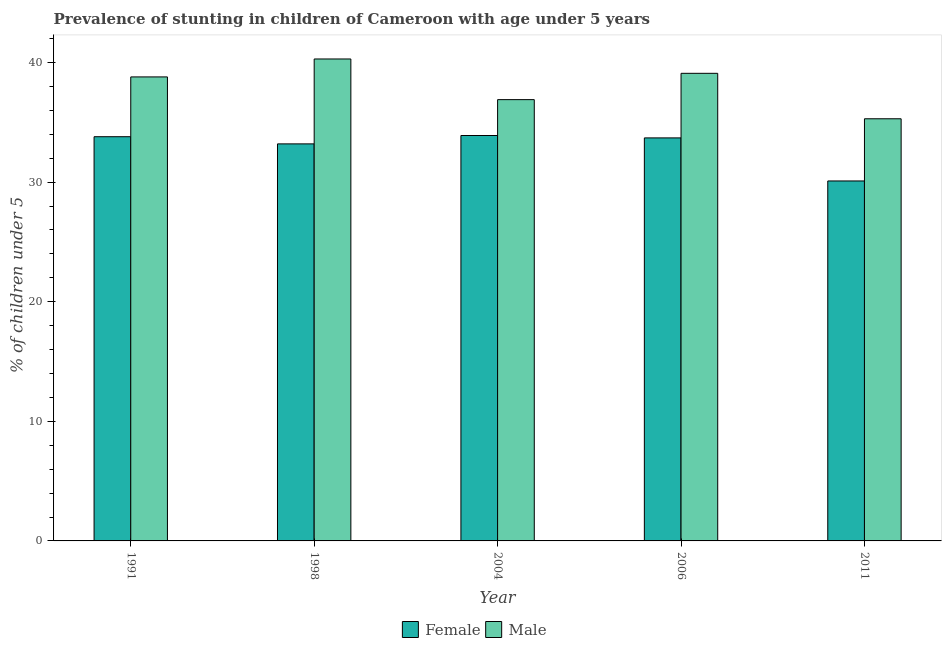Are the number of bars per tick equal to the number of legend labels?
Your answer should be compact. Yes. How many bars are there on the 1st tick from the left?
Offer a terse response. 2. What is the label of the 3rd group of bars from the left?
Your response must be concise. 2004. What is the percentage of stunted female children in 2011?
Your response must be concise. 30.1. Across all years, what is the maximum percentage of stunted female children?
Give a very brief answer. 33.9. Across all years, what is the minimum percentage of stunted female children?
Keep it short and to the point. 30.1. In which year was the percentage of stunted female children maximum?
Provide a succinct answer. 2004. What is the total percentage of stunted male children in the graph?
Your answer should be very brief. 190.4. What is the difference between the percentage of stunted female children in 1998 and that in 2011?
Give a very brief answer. 3.1. What is the difference between the percentage of stunted male children in 2006 and the percentage of stunted female children in 2004?
Make the answer very short. 2.2. What is the average percentage of stunted male children per year?
Provide a succinct answer. 38.08. In the year 1998, what is the difference between the percentage of stunted male children and percentage of stunted female children?
Your answer should be compact. 0. In how many years, is the percentage of stunted female children greater than 22 %?
Give a very brief answer. 5. What is the ratio of the percentage of stunted male children in 1991 to that in 2004?
Offer a very short reply. 1.05. Is the percentage of stunted female children in 1991 less than that in 2006?
Give a very brief answer. No. What is the difference between the highest and the second highest percentage of stunted male children?
Ensure brevity in your answer.  1.2. In how many years, is the percentage of stunted female children greater than the average percentage of stunted female children taken over all years?
Give a very brief answer. 4. What does the 2nd bar from the left in 1998 represents?
Keep it short and to the point. Male. Are all the bars in the graph horizontal?
Your answer should be compact. No. How many years are there in the graph?
Your answer should be very brief. 5. What is the difference between two consecutive major ticks on the Y-axis?
Your answer should be compact. 10. Does the graph contain grids?
Make the answer very short. No. How are the legend labels stacked?
Provide a succinct answer. Horizontal. What is the title of the graph?
Offer a very short reply. Prevalence of stunting in children of Cameroon with age under 5 years. What is the label or title of the Y-axis?
Keep it short and to the point.  % of children under 5. What is the  % of children under 5 of Female in 1991?
Your answer should be very brief. 33.8. What is the  % of children under 5 in Male in 1991?
Offer a very short reply. 38.8. What is the  % of children under 5 of Female in 1998?
Offer a terse response. 33.2. What is the  % of children under 5 in Male in 1998?
Your answer should be very brief. 40.3. What is the  % of children under 5 of Female in 2004?
Your response must be concise. 33.9. What is the  % of children under 5 of Male in 2004?
Provide a succinct answer. 36.9. What is the  % of children under 5 in Female in 2006?
Make the answer very short. 33.7. What is the  % of children under 5 of Male in 2006?
Your answer should be compact. 39.1. What is the  % of children under 5 of Female in 2011?
Your response must be concise. 30.1. What is the  % of children under 5 in Male in 2011?
Your response must be concise. 35.3. Across all years, what is the maximum  % of children under 5 of Female?
Your response must be concise. 33.9. Across all years, what is the maximum  % of children under 5 in Male?
Ensure brevity in your answer.  40.3. Across all years, what is the minimum  % of children under 5 of Female?
Keep it short and to the point. 30.1. Across all years, what is the minimum  % of children under 5 of Male?
Give a very brief answer. 35.3. What is the total  % of children under 5 of Female in the graph?
Ensure brevity in your answer.  164.7. What is the total  % of children under 5 in Male in the graph?
Give a very brief answer. 190.4. What is the difference between the  % of children under 5 of Male in 1991 and that in 2006?
Make the answer very short. -0.3. What is the difference between the  % of children under 5 in Male in 1991 and that in 2011?
Offer a terse response. 3.5. What is the difference between the  % of children under 5 in Female in 1998 and that in 2004?
Offer a very short reply. -0.7. What is the difference between the  % of children under 5 in Male in 1998 and that in 2006?
Make the answer very short. 1.2. What is the difference between the  % of children under 5 in Female in 1998 and that in 2011?
Your response must be concise. 3.1. What is the difference between the  % of children under 5 of Male in 1998 and that in 2011?
Your answer should be very brief. 5. What is the difference between the  % of children under 5 of Male in 2004 and that in 2006?
Give a very brief answer. -2.2. What is the difference between the  % of children under 5 of Female in 2004 and that in 2011?
Your answer should be very brief. 3.8. What is the difference between the  % of children under 5 of Male in 2006 and that in 2011?
Make the answer very short. 3.8. What is the difference between the  % of children under 5 in Female in 1991 and the  % of children under 5 in Male in 2006?
Your answer should be compact. -5.3. What is the difference between the  % of children under 5 of Female in 1998 and the  % of children under 5 of Male in 2011?
Keep it short and to the point. -2.1. What is the difference between the  % of children under 5 of Female in 2004 and the  % of children under 5 of Male in 2011?
Your answer should be compact. -1.4. What is the difference between the  % of children under 5 of Female in 2006 and the  % of children under 5 of Male in 2011?
Offer a very short reply. -1.6. What is the average  % of children under 5 in Female per year?
Give a very brief answer. 32.94. What is the average  % of children under 5 in Male per year?
Keep it short and to the point. 38.08. In the year 1998, what is the difference between the  % of children under 5 in Female and  % of children under 5 in Male?
Your response must be concise. -7.1. In the year 2004, what is the difference between the  % of children under 5 in Female and  % of children under 5 in Male?
Your answer should be very brief. -3. What is the ratio of the  % of children under 5 in Female in 1991 to that in 1998?
Offer a terse response. 1.02. What is the ratio of the  % of children under 5 in Male in 1991 to that in 1998?
Ensure brevity in your answer.  0.96. What is the ratio of the  % of children under 5 in Male in 1991 to that in 2004?
Make the answer very short. 1.05. What is the ratio of the  % of children under 5 in Female in 1991 to that in 2006?
Your answer should be very brief. 1. What is the ratio of the  % of children under 5 of Female in 1991 to that in 2011?
Keep it short and to the point. 1.12. What is the ratio of the  % of children under 5 of Male in 1991 to that in 2011?
Provide a succinct answer. 1.1. What is the ratio of the  % of children under 5 of Female in 1998 to that in 2004?
Provide a short and direct response. 0.98. What is the ratio of the  % of children under 5 in Male in 1998 to that in 2004?
Keep it short and to the point. 1.09. What is the ratio of the  % of children under 5 in Female in 1998 to that in 2006?
Your response must be concise. 0.99. What is the ratio of the  % of children under 5 of Male in 1998 to that in 2006?
Provide a succinct answer. 1.03. What is the ratio of the  % of children under 5 in Female in 1998 to that in 2011?
Provide a short and direct response. 1.1. What is the ratio of the  % of children under 5 of Male in 1998 to that in 2011?
Provide a short and direct response. 1.14. What is the ratio of the  % of children under 5 of Female in 2004 to that in 2006?
Offer a very short reply. 1.01. What is the ratio of the  % of children under 5 in Male in 2004 to that in 2006?
Make the answer very short. 0.94. What is the ratio of the  % of children under 5 of Female in 2004 to that in 2011?
Your answer should be compact. 1.13. What is the ratio of the  % of children under 5 in Male in 2004 to that in 2011?
Ensure brevity in your answer.  1.05. What is the ratio of the  % of children under 5 of Female in 2006 to that in 2011?
Your answer should be compact. 1.12. What is the ratio of the  % of children under 5 of Male in 2006 to that in 2011?
Your answer should be very brief. 1.11. What is the difference between the highest and the second highest  % of children under 5 in Female?
Ensure brevity in your answer.  0.1. What is the difference between the highest and the second highest  % of children under 5 in Male?
Your answer should be very brief. 1.2. What is the difference between the highest and the lowest  % of children under 5 in Female?
Keep it short and to the point. 3.8. What is the difference between the highest and the lowest  % of children under 5 in Male?
Your answer should be compact. 5. 